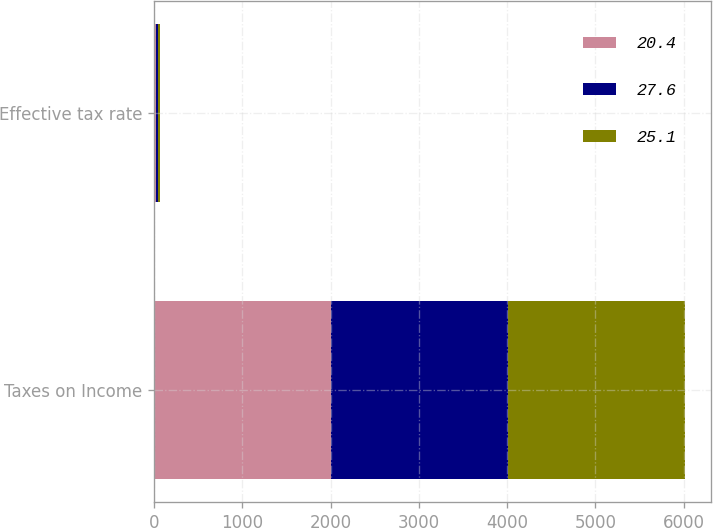<chart> <loc_0><loc_0><loc_500><loc_500><stacked_bar_chart><ecel><fcel>Taxes on Income<fcel>Effective tax rate<nl><fcel>20.4<fcel>2005<fcel>20.4<nl><fcel>27.6<fcel>2004<fcel>25.1<nl><fcel>25.1<fcel>2003<fcel>27.6<nl></chart> 